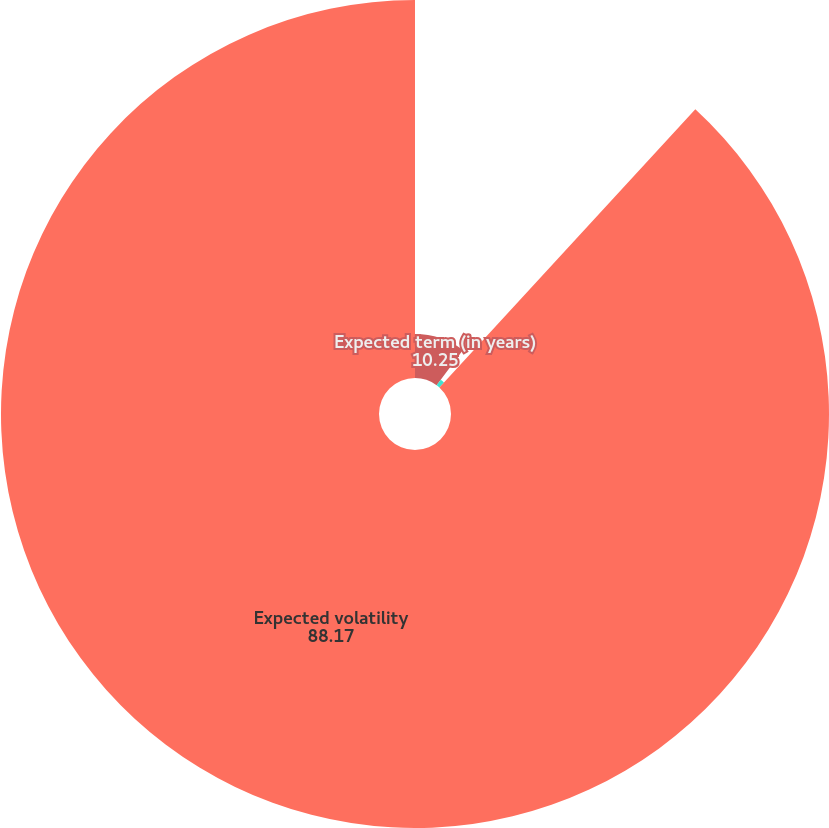Convert chart. <chart><loc_0><loc_0><loc_500><loc_500><pie_chart><fcel>Expected term (in years)<fcel>Risk-free interest rate<fcel>Expected volatility<nl><fcel>10.25%<fcel>1.59%<fcel>88.17%<nl></chart> 